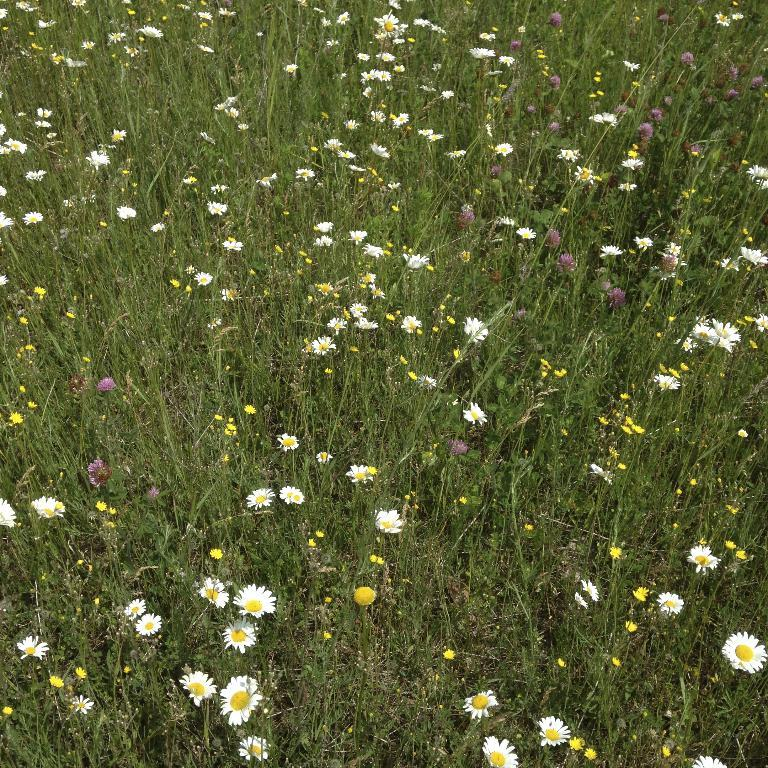What is the main subject of the image? The main subject of the image is flower plants. How are the flowers arranged in the image? There are many flowers in the image, arranged one beside the other. What type of pest can be seen crawling on the flowers in the image? There is no pest visible on the flowers in the image. Can you tell me how many rays are emanating from the flowers in the image? There are no rays present in the image; it features flower plants and flowers. 